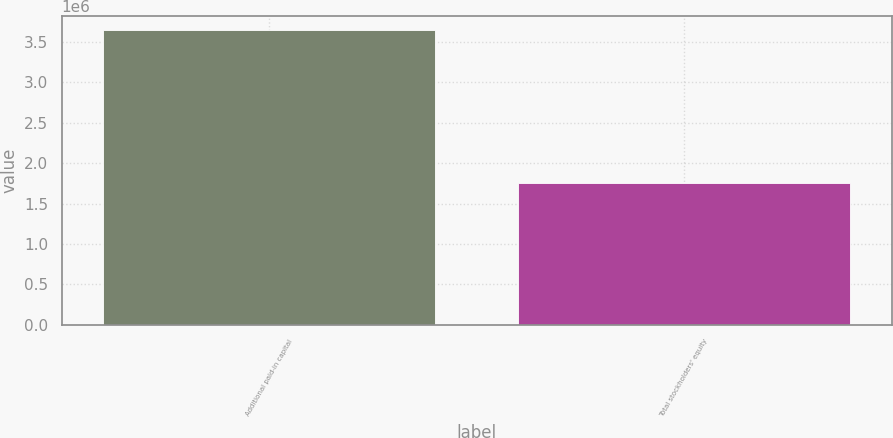Convert chart to OTSL. <chart><loc_0><loc_0><loc_500><loc_500><bar_chart><fcel>Additional paid-in capital<fcel>Total stockholders' equity<nl><fcel>3.64202e+06<fcel>1.75261e+06<nl></chart> 